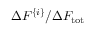<formula> <loc_0><loc_0><loc_500><loc_500>\Delta F ^ { \{ i \} } / { \Delta F _ { t o t } }</formula> 